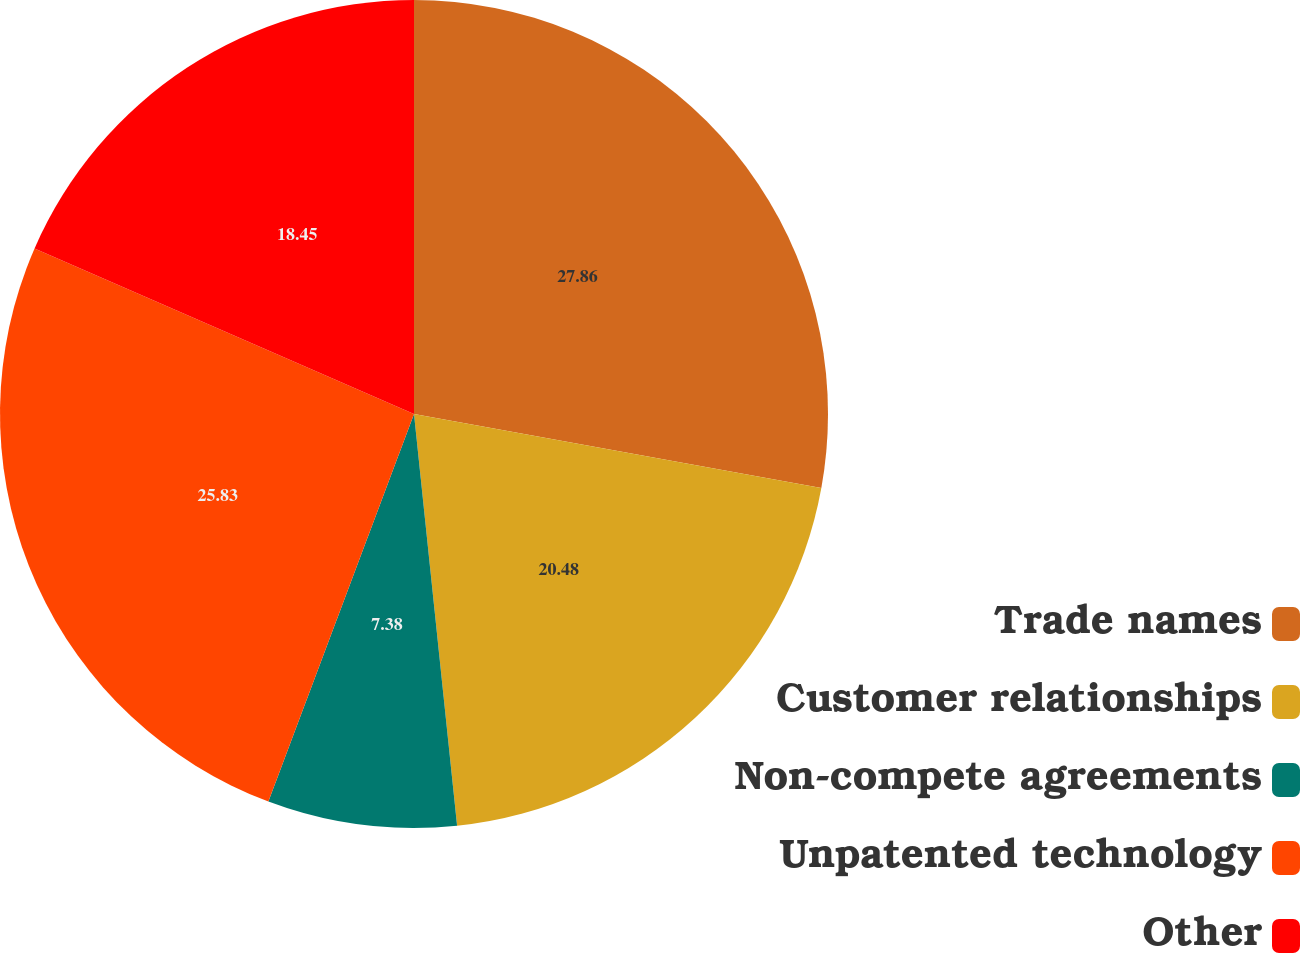<chart> <loc_0><loc_0><loc_500><loc_500><pie_chart><fcel>Trade names<fcel>Customer relationships<fcel>Non-compete agreements<fcel>Unpatented technology<fcel>Other<nl><fcel>27.86%<fcel>20.48%<fcel>7.38%<fcel>25.83%<fcel>18.45%<nl></chart> 